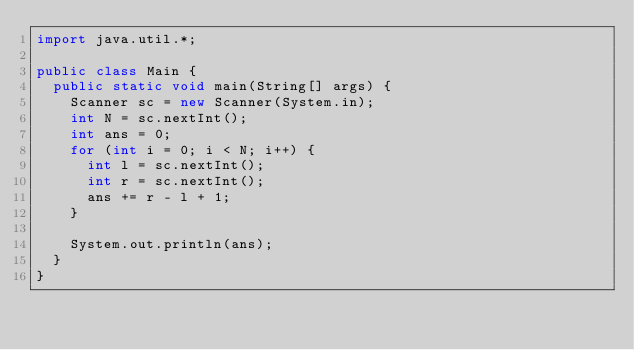<code> <loc_0><loc_0><loc_500><loc_500><_Java_>import java.util.*;

public class Main {
  public static void main(String[] args) {
    Scanner sc = new Scanner(System.in);
    int N = sc.nextInt();
    int ans = 0;
    for (int i = 0; i < N; i++) {
      int l = sc.nextInt();
      int r = sc.nextInt();
      ans += r - l + 1;
    }

    System.out.println(ans);
  }
}</code> 